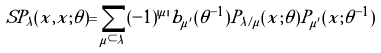Convert formula to latex. <formula><loc_0><loc_0><loc_500><loc_500>S P _ { \lambda } ( x , \tilde { x } ; \theta ) = \sum _ { \mu \subset \lambda } ( - 1 ) ^ { | \mu | } b _ { \mu ^ { \prime } } ( \theta ^ { - 1 } ) P _ { \lambda / \mu } ( x ; \theta ) P _ { \mu ^ { \prime } } ( \tilde { x } ; \theta ^ { - 1 } )</formula> 